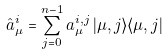<formula> <loc_0><loc_0><loc_500><loc_500>\hat { a } _ { \mu } ^ { i } = \sum _ { j = 0 } ^ { n - 1 } a _ { \mu } ^ { i , j } \, | \mu , j \rangle \langle \mu , j |</formula> 